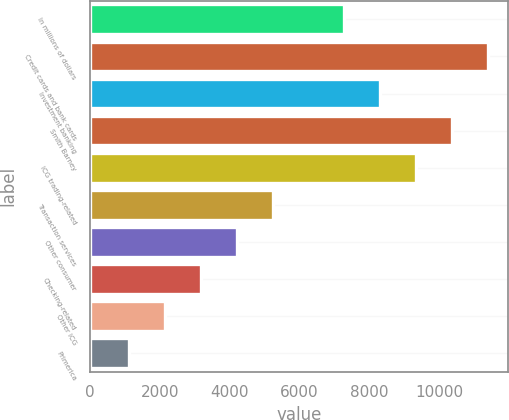Convert chart to OTSL. <chart><loc_0><loc_0><loc_500><loc_500><bar_chart><fcel>In millions of dollars<fcel>Credit cards and bank cards<fcel>Investment banking<fcel>Smith Barney<fcel>ICG trading-related<fcel>Transaction services<fcel>Other consumer<fcel>Checking-related<fcel>Other ICG<fcel>Primerica<nl><fcel>7281.4<fcel>11394.2<fcel>8309.6<fcel>10366<fcel>9337.8<fcel>5225<fcel>4196.8<fcel>3168.6<fcel>2140.4<fcel>1112.2<nl></chart> 